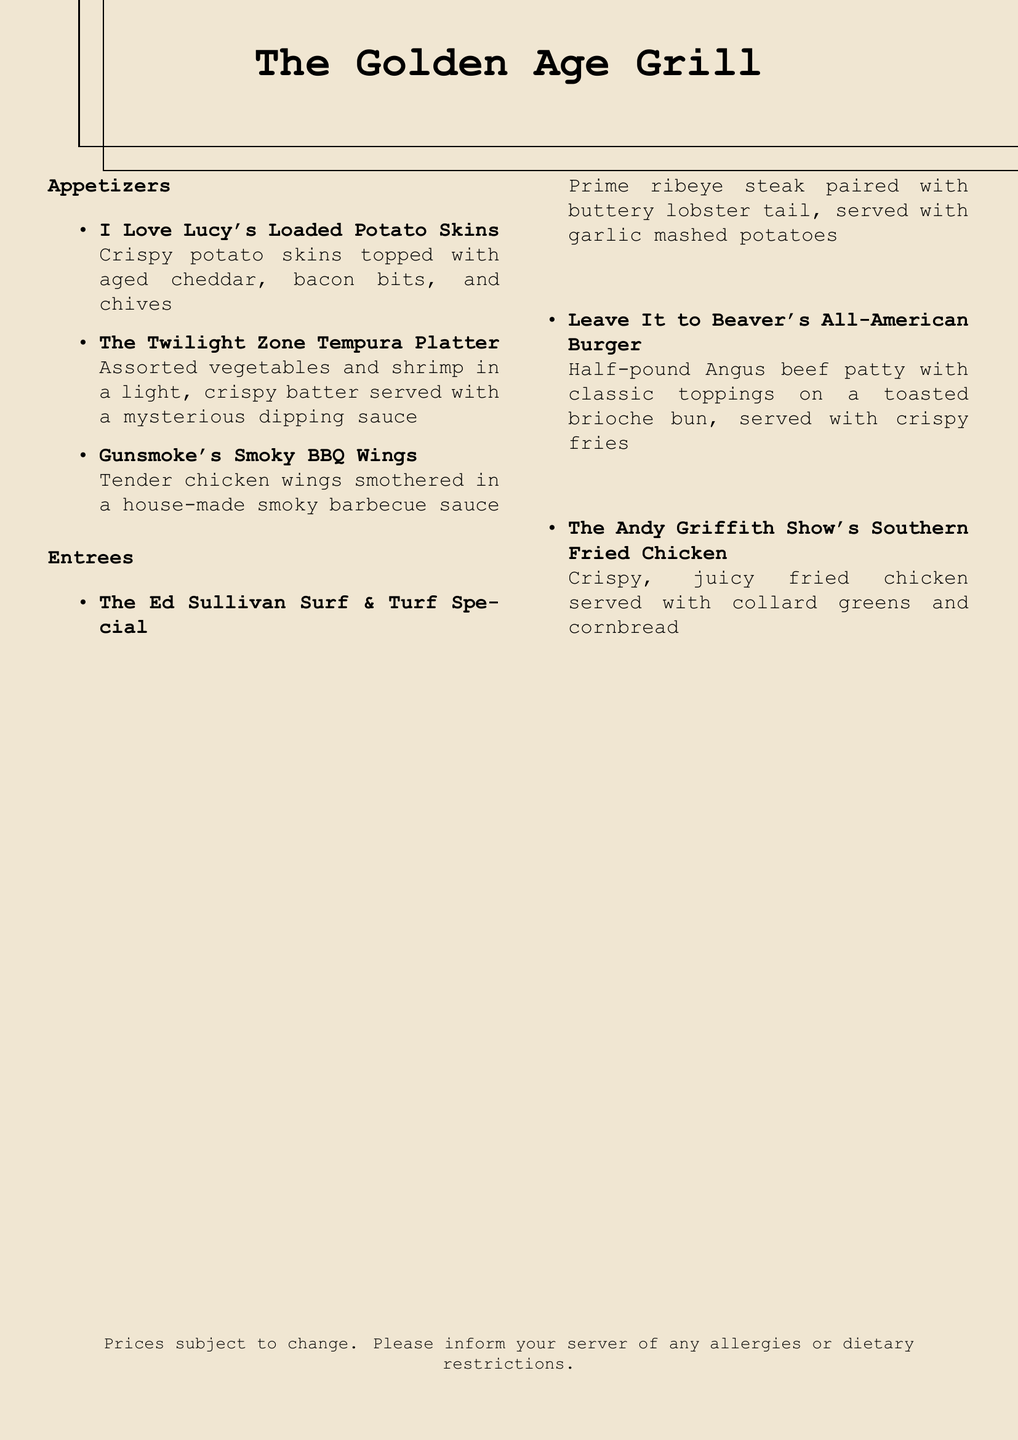What is the name of the appetizer associated with "I Love Lucy"? The appetizer is listed under the "Appetizers" section and is referred to as "I Love Lucy's Loaded Potato Skins."
Answer: I Love Lucy's Loaded Potato Skins What vegetables are included in "The Twilight Zone Tempura Platter"? The dish description mentions "assorted vegetables and shrimp," but does not specify which vegetables are used.
Answer: Assorted vegetables What is served with "The Ed Sullivan Surf & Turf Special"? This entree comes with garlic mashed potatoes as stated in the description.
Answer: Garlic mashed potatoes How many appetizers are listed on the menu? By counting the bullet points under the "Appetizers" section, there are three appetizers specified.
Answer: Three Which dish is paired with collard greens? The entree described as "The Andy Griffith Show's Southern Fried Chicken" includes collard greens in its description.
Answer: The Andy Griffith Show's Southern Fried Chicken What type of meat is used in "Leave It to Beaver's All-American Burger"? The burger is made from a half-pound Angus beef patty as stated in the description.
Answer: Angus beef What dish features a combination of prime ribeye steak and lobster? The entree is highlighted as "The Ed Sullivan Surf & Turf Special," which features both prime ribeye steak and lobster tail.
Answer: The Ed Sullivan Surf & Turf Special What is the theme of the restaurant menu design? The menu features a vintage black-and-white design, as mentioned in the requirements of the task.
Answer: Vintage black-and-white design 